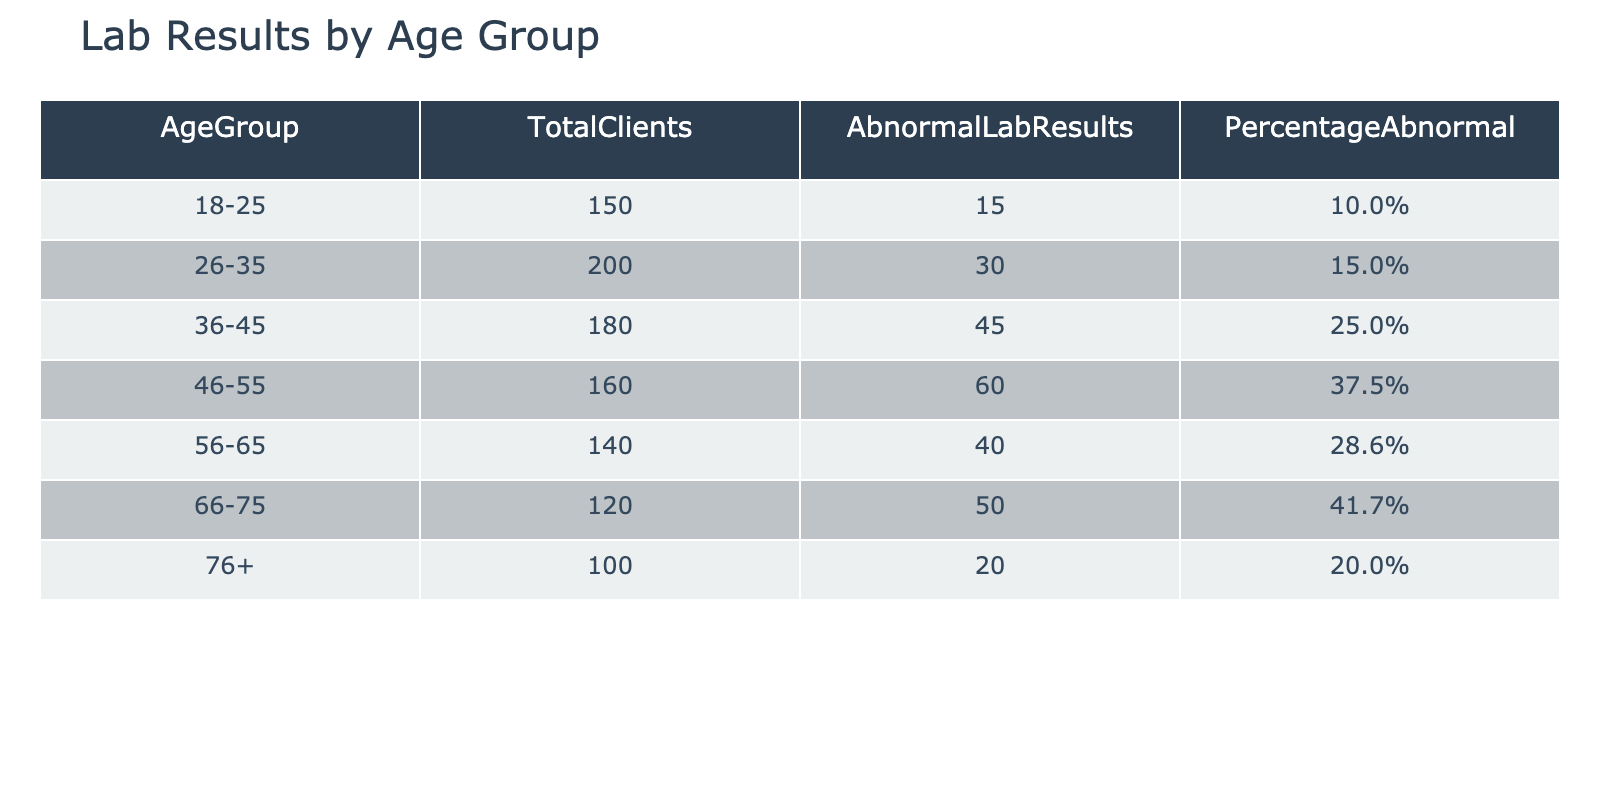What is the total number of clients in the 46-55 age group? From the table, the TotalClients for the 46-55 age group is explicitly listed as 160.
Answer: 160 What percentage of clients in the 36-45 age group have abnormal lab results? The PercentageAbnormal for the 36-45 age group is provided in the table as 25.0%.
Answer: 25.0% How many clients aged 66-75 have abnormal lab results? Referring to the table, the AbnormalLabResults for the 66-75 age group is indicated as 50.
Answer: 50 What is the average percentage of abnormal lab results across all age groups? To calculate the average, we first sum the percentages: 10 + 15 + 25 + 37.5 + 28.6 + 41.7 + 20 =  173.8%. Since there are 7 age groups, we divide by 7: 173.8 / 7 = 24.77%.
Answer: 24.77% Is the percentage of abnormal lab results for the 56-65 age group higher than that for the 46-55 age group? The PercentageAbnormal for the 56-65 age group is 28.6%, while for the 46-55 age group, it is 37.5%. Since 28.6% is less than 37.5%, the statement is false.
Answer: No Which age group has the highest percentage of abnormal lab results, and what is that percentage? By evaluating the PercentageAbnormal column, the 46-55 age group has the highest percentage at 37.5%.
Answer: 46-55, 37.5% What is the difference in the number of clients with abnormal lab results between the 26-35 age group and the 66-75 age group? For the 26-35 age group, there are 30 abnormal lab results, and for the 66-75 age group, there are 50. The difference is computed as 50 - 30 = 20.
Answer: 20 What proportion of the total clients represented in the table are in the 18-25 age group? To find this proportion, we first total the number of clients across all age groups: 150 + 200 + 180 + 160 + 140 + 120 + 100 = 1,050. The proportion of clients aged 18-25 is then 150 / 1,050 = 0.142857 or approximately 14.29%.
Answer: 14.29% Is it true that more than 30% of clients aged 46-55 have abnormal lab results? The PercentageAbnormal for the 46-55 age group is 37.5%, which is indeed greater than 30%. Thus, the statement is true.
Answer: Yes 